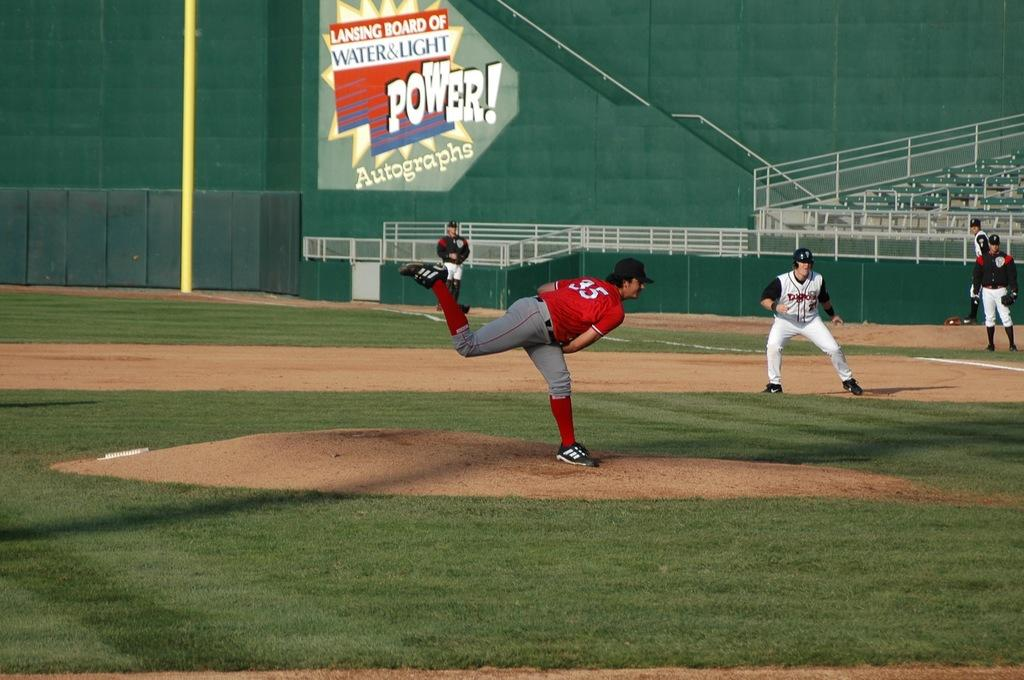Provide a one-sentence caption for the provided image. The pitcher in the baseball game is wearing an orange jersey with the number 35. 